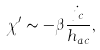<formula> <loc_0><loc_0><loc_500><loc_500>\chi ^ { \prime } \sim - \beta \frac { j _ { c } } { h _ { a c } } ,</formula> 